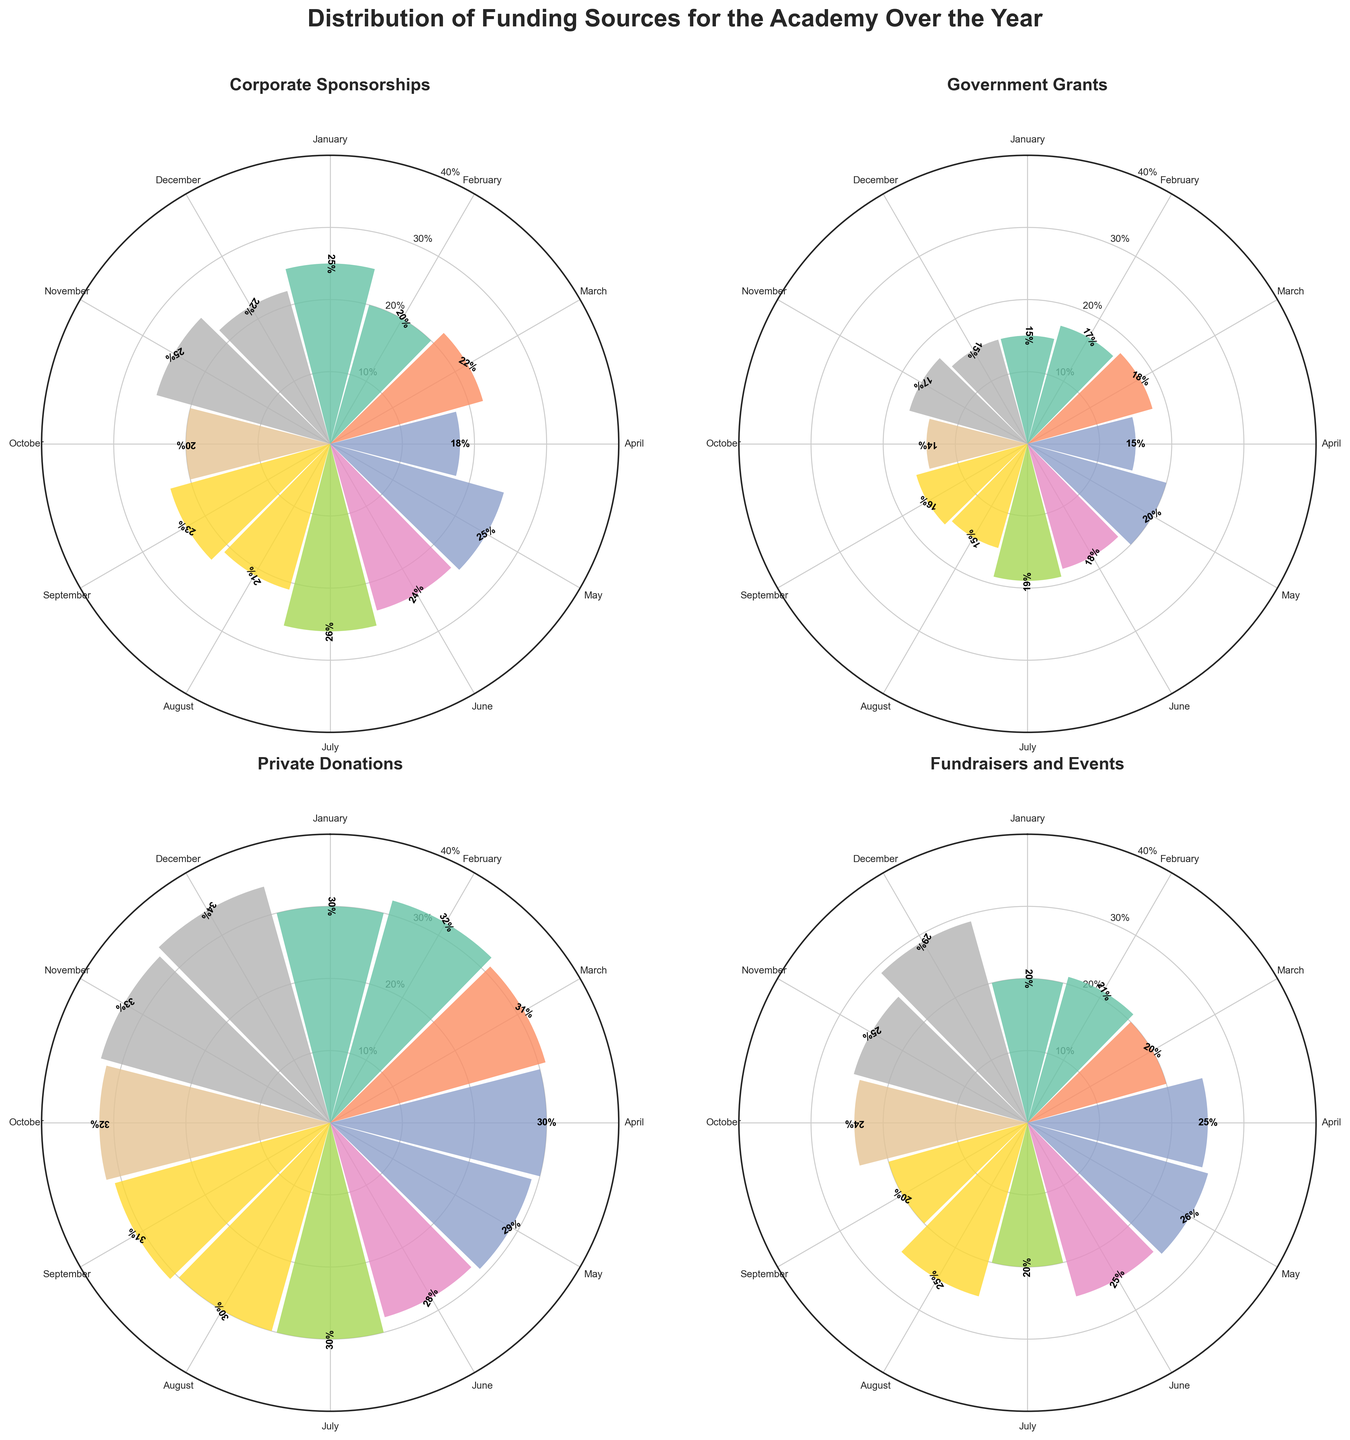Which category had the highest funding percentage in December? Examine the "December" section of each subplot. Corporate Sponsorships = 22%, Government Grants = 15%, Private Donations = 34%, and Fundraisers and Events = 29%. Private Donations has the highest value.
Answer: Private Donations What is the average funding percentage for Corporate Sponsorships throughout the year? Sum the percentages for Corporate Sponsorships (25 + 20 + 22 + 18 + 25 + 24 + 26 + 21 + 23 + 20 + 25 + 22) = 271, then divide by 12. 271/12 = approx 22.58%.
Answer: 22.58% Which month had the highest overall percentage of Private Donations? Check the percentages for Private Donations across each month and identify the highest value. The highest value for Private Donations is in December with 34%.
Answer: December Is the percentage of Fundraisers and Events in April higher than in February? Compare the funding percentages for Fundraisers and Events in April (25%) and February (21%) by directly looking at the plot. Yes, 25% is higher than 21%.
Answer: Yes From which category does the academy consistently get the most funding throughout the year? Compare all percentages of the months for each category and look for consistency. Private Donations consistently have the highest values across all months compared to others.
Answer: Private Donations Which month shows a noticeable increase in funding from Fundraisers and Events compared to the previous month? Check each month’s percentage of Fundraisers and Events and mark if there’s a noticeable increase from the previous month. March (20%) to April (25%) shows a noticeable 5% increase.
Answer: April What is the total percentage contribution of Government Grants in the last quarter of the year? Sum the percentages for Government Grants in October (14%), November (17%), and December (15%): 14 + 17 + 15 = 46.
Answer: 46% Which funding source shows the most fluctuation throughout the year? Examine the range of percentages for each category. Fundraisers and Events vary from 20% to 29%, which shows the most fluctuation (9 percentage points difference).
Answer: Fundraisers and Events Are Corporate Sponsorships more significant than Government Grants in any given month? Compare the values for Corporate Sponsorships and Government Grants across all months. Every month, Corporate Sponsorships have a higher percentage than Government Grants.
Answer: Yes How do the funding percentages for Government Grants compare between January and December? Check the percentages of Government Grants for January (15%) and December (15%). Both values are the same.
Answer: They are the same 